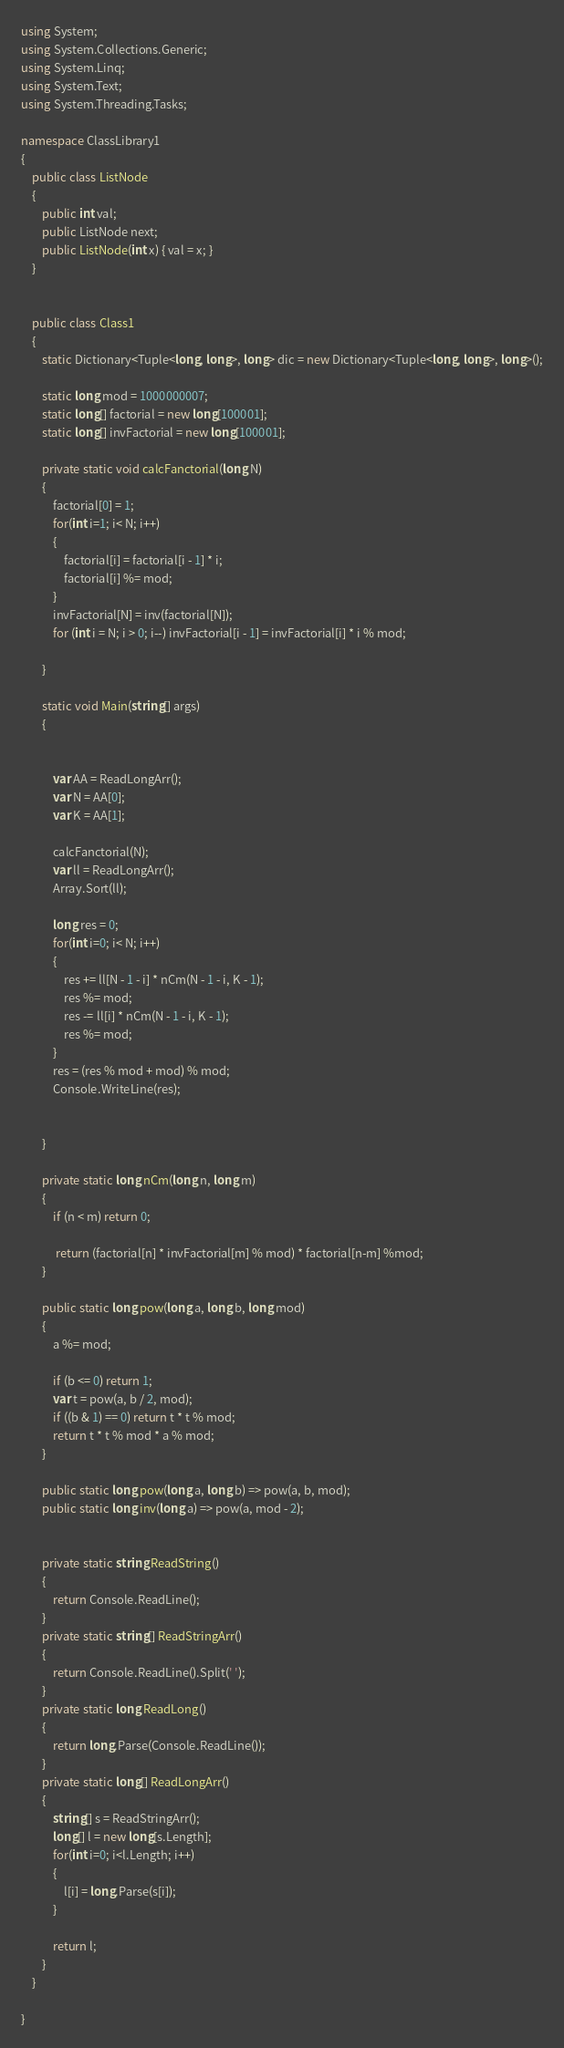Convert code to text. <code><loc_0><loc_0><loc_500><loc_500><_C#_>using System;
using System.Collections.Generic;
using System.Linq;
using System.Text;
using System.Threading.Tasks;

namespace ClassLibrary1
{
    public class ListNode
    {
        public int val;
        public ListNode next;
        public ListNode(int x) { val = x; }
    }


    public class Class1
    {
        static Dictionary<Tuple<long, long>, long> dic = new Dictionary<Tuple<long, long>, long>();

        static long mod = 1000000007;
        static long[] factorial = new long[100001];
        static long[] invFactorial = new long[100001];

        private static void calcFanctorial(long N)
        {
            factorial[0] = 1;
            for(int i=1; i< N; i++)
            {
                factorial[i] = factorial[i - 1] * i;
                factorial[i] %= mod;
            }
            invFactorial[N] = inv(factorial[N]);
            for (int i = N; i > 0; i--) invFactorial[i - 1] = invFactorial[i] * i % mod;

        }

        static void Main(string[] args)
        {


            var AA = ReadLongArr();
            var N = AA[0];
            var K = AA[1];

            calcFanctorial(N);
            var ll = ReadLongArr();
            Array.Sort(ll);

            long res = 0;
            for(int i=0; i< N; i++)
            {
                res += ll[N - 1 - i] * nCm(N - 1 - i, K - 1);
                res %= mod;
                res -= ll[i] * nCm(N - 1 - i, K - 1);
                res %= mod;
            }
            res = (res % mod + mod) % mod;
            Console.WriteLine(res);


        }

        private static long nCm(long n, long m)
        {
            if (n < m) return 0;

             return (factorial[n] * invFactorial[m] % mod) * factorial[n-m] %mod;
        }

        public static long pow(long a, long b, long mod)
        {
            a %= mod;

            if (b <= 0) return 1;
            var t = pow(a, b / 2, mod);
            if ((b & 1) == 0) return t * t % mod;
            return t * t % mod * a % mod;
        }

        public static long pow(long a, long b) => pow(a, b, mod);
        public static long inv(long a) => pow(a, mod - 2);


        private static string ReadString()
        {
            return Console.ReadLine();
        }
        private static string[] ReadStringArr()
        {
            return Console.ReadLine().Split(' ');
        }
        private static long ReadLong()
        {
            return long.Parse(Console.ReadLine());
        }
        private static long[] ReadLongArr()
        {
            string[] s = ReadStringArr();
            long[] l = new long[s.Length];
            for(int i=0; i<l.Length; i++)
            {
                l[i] = long.Parse(s[i]);
            }

            return l;
        }
    }

}
</code> 